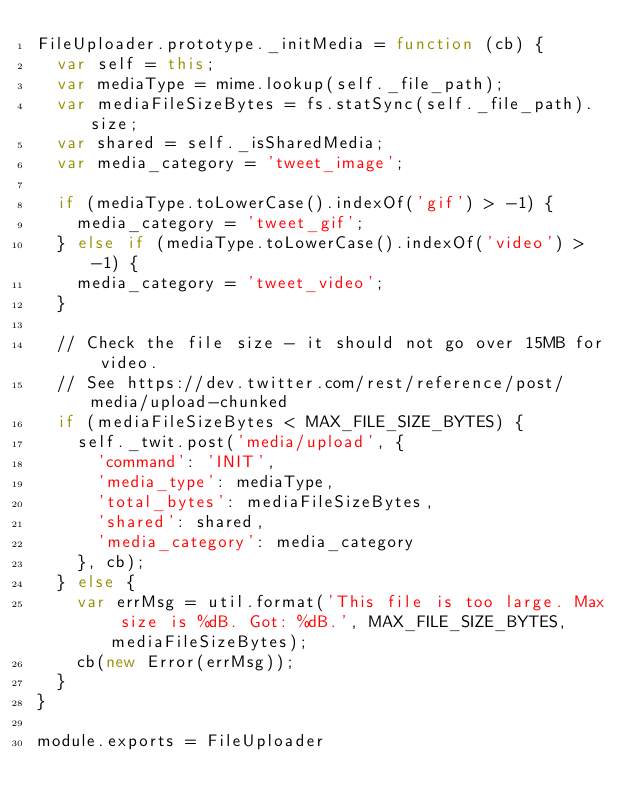Convert code to text. <code><loc_0><loc_0><loc_500><loc_500><_JavaScript_>FileUploader.prototype._initMedia = function (cb) {
  var self = this;
  var mediaType = mime.lookup(self._file_path);
  var mediaFileSizeBytes = fs.statSync(self._file_path).size;
  var shared = self._isSharedMedia;
  var media_category = 'tweet_image';

  if (mediaType.toLowerCase().indexOf('gif') > -1) {
    media_category = 'tweet_gif';
  } else if (mediaType.toLowerCase().indexOf('video') > -1) {
    media_category = 'tweet_video';
  }

  // Check the file size - it should not go over 15MB for video.
  // See https://dev.twitter.com/rest/reference/post/media/upload-chunked
  if (mediaFileSizeBytes < MAX_FILE_SIZE_BYTES) {
    self._twit.post('media/upload', {
      'command': 'INIT',
      'media_type': mediaType,
      'total_bytes': mediaFileSizeBytes,
      'shared': shared,
      'media_category': media_category
    }, cb);
  } else {
    var errMsg = util.format('This file is too large. Max size is %dB. Got: %dB.', MAX_FILE_SIZE_BYTES, mediaFileSizeBytes);
    cb(new Error(errMsg));
  }
}

module.exports = FileUploader
</code> 